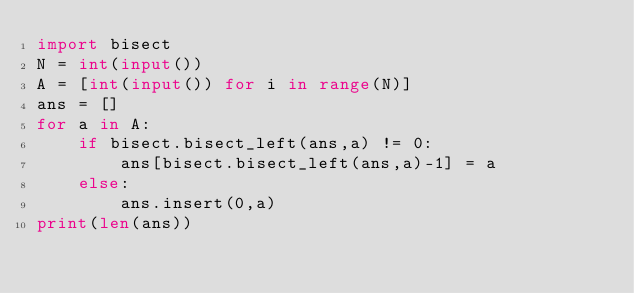<code> <loc_0><loc_0><loc_500><loc_500><_Python_>import bisect
N = int(input())
A = [int(input()) for i in range(N)]
ans = []
for a in A:
    if bisect.bisect_left(ans,a) != 0:
        ans[bisect.bisect_left(ans,a)-1] = a
    else:
        ans.insert(0,a)
print(len(ans))
</code> 